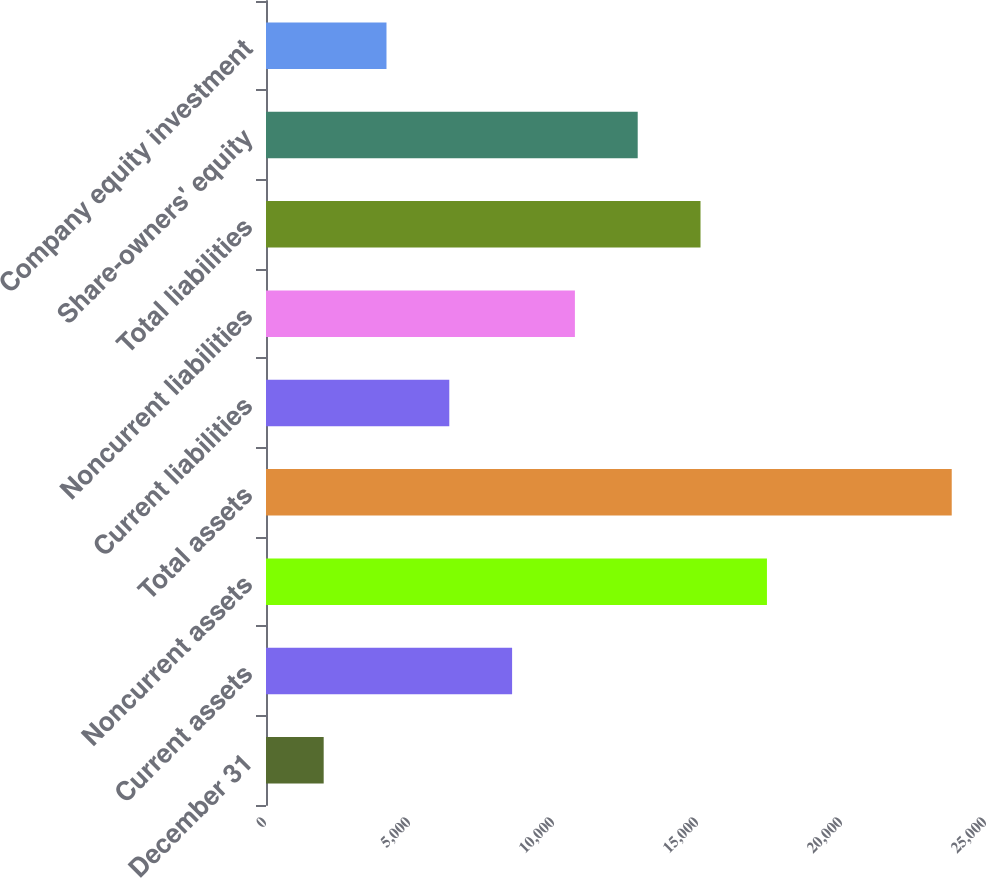<chart> <loc_0><loc_0><loc_500><loc_500><bar_chart><fcel>December 31<fcel>Current assets<fcel>Noncurrent assets<fcel>Total assets<fcel>Current liabilities<fcel>Noncurrent liabilities<fcel>Total liabilities<fcel>Share-owners' equity<fcel>Company equity investment<nl><fcel>2003<fcel>8545.1<fcel>17394<fcel>23810<fcel>6364.4<fcel>10725.8<fcel>15087.2<fcel>12906.5<fcel>4183.7<nl></chart> 